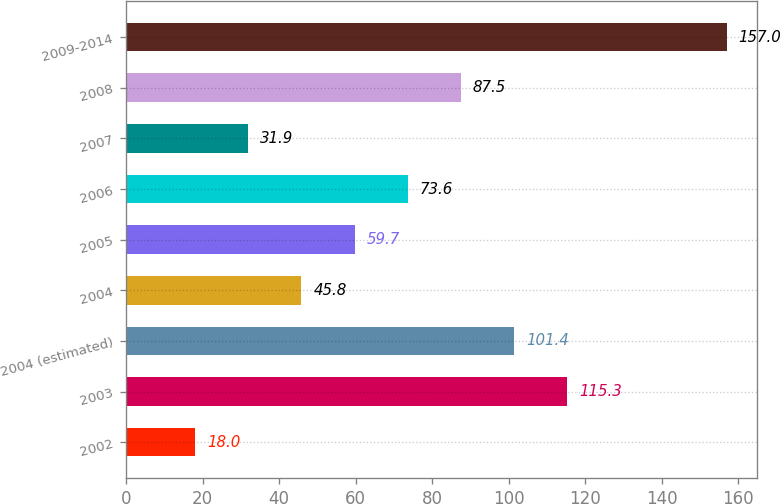Convert chart. <chart><loc_0><loc_0><loc_500><loc_500><bar_chart><fcel>2002<fcel>2003<fcel>2004 (estimated)<fcel>2004<fcel>2005<fcel>2006<fcel>2007<fcel>2008<fcel>2009-2014<nl><fcel>18<fcel>115.3<fcel>101.4<fcel>45.8<fcel>59.7<fcel>73.6<fcel>31.9<fcel>87.5<fcel>157<nl></chart> 